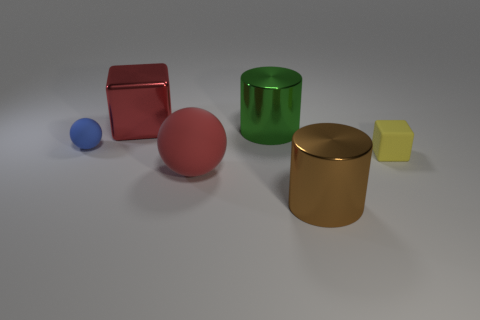What is the size of the matte sphere left of the big red object behind the small rubber sphere?
Offer a very short reply. Small. Are there the same number of large blocks that are in front of the small blue matte sphere and big metallic things that are on the right side of the green thing?
Make the answer very short. No. What is the material of the thing that is behind the small matte ball and left of the big matte object?
Your response must be concise. Metal. There is a green thing; is it the same size as the sphere behind the tiny yellow block?
Ensure brevity in your answer.  No. How many other objects are there of the same color as the large metallic cube?
Give a very brief answer. 1. Are there more big red rubber spheres that are on the left side of the blue sphere than big brown matte cylinders?
Offer a very short reply. No. There is a cylinder in front of the rubber thing on the right side of the red thing in front of the small yellow thing; what color is it?
Provide a short and direct response. Brown. Are the small block and the large green cylinder made of the same material?
Your answer should be very brief. No. Are there any red metallic blocks that have the same size as the blue object?
Provide a succinct answer. No. What material is the blue ball that is the same size as the yellow rubber block?
Keep it short and to the point. Rubber. 